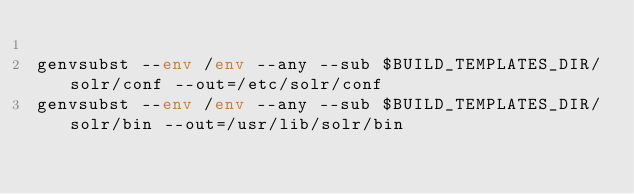<code> <loc_0><loc_0><loc_500><loc_500><_Bash_>
genvsubst --env /env --any --sub $BUILD_TEMPLATES_DIR/solr/conf --out=/etc/solr/conf
genvsubst --env /env --any --sub $BUILD_TEMPLATES_DIR/solr/bin --out=/usr/lib/solr/bin
</code> 